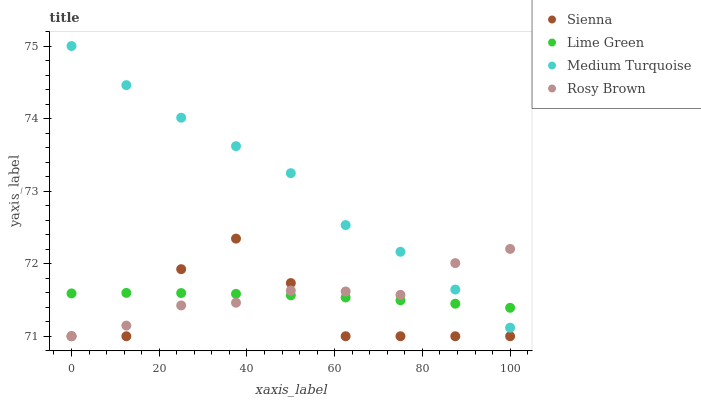Does Sienna have the minimum area under the curve?
Answer yes or no. Yes. Does Medium Turquoise have the maximum area under the curve?
Answer yes or no. Yes. Does Rosy Brown have the minimum area under the curve?
Answer yes or no. No. Does Rosy Brown have the maximum area under the curve?
Answer yes or no. No. Is Lime Green the smoothest?
Answer yes or no. Yes. Is Sienna the roughest?
Answer yes or no. Yes. Is Rosy Brown the smoothest?
Answer yes or no. No. Is Rosy Brown the roughest?
Answer yes or no. No. Does Sienna have the lowest value?
Answer yes or no. Yes. Does Lime Green have the lowest value?
Answer yes or no. No. Does Medium Turquoise have the highest value?
Answer yes or no. Yes. Does Rosy Brown have the highest value?
Answer yes or no. No. Is Sienna less than Medium Turquoise?
Answer yes or no. Yes. Is Medium Turquoise greater than Sienna?
Answer yes or no. Yes. Does Lime Green intersect Sienna?
Answer yes or no. Yes. Is Lime Green less than Sienna?
Answer yes or no. No. Is Lime Green greater than Sienna?
Answer yes or no. No. Does Sienna intersect Medium Turquoise?
Answer yes or no. No. 